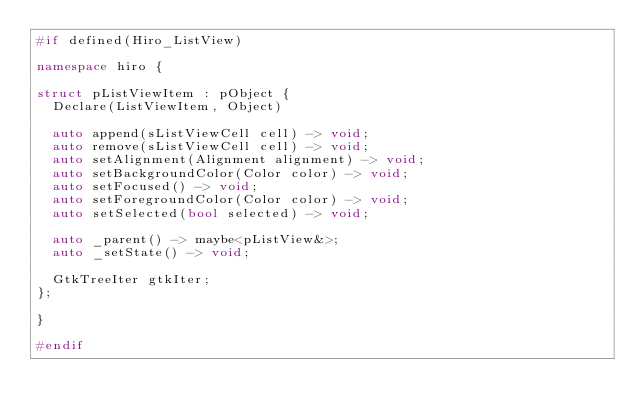Convert code to text. <code><loc_0><loc_0><loc_500><loc_500><_C++_>#if defined(Hiro_ListView)

namespace hiro {

struct pListViewItem : pObject {
  Declare(ListViewItem, Object)

  auto append(sListViewCell cell) -> void;
  auto remove(sListViewCell cell) -> void;
  auto setAlignment(Alignment alignment) -> void;
  auto setBackgroundColor(Color color) -> void;
  auto setFocused() -> void;
  auto setForegroundColor(Color color) -> void;
  auto setSelected(bool selected) -> void;

  auto _parent() -> maybe<pListView&>;
  auto _setState() -> void;

  GtkTreeIter gtkIter;
};

}

#endif
</code> 